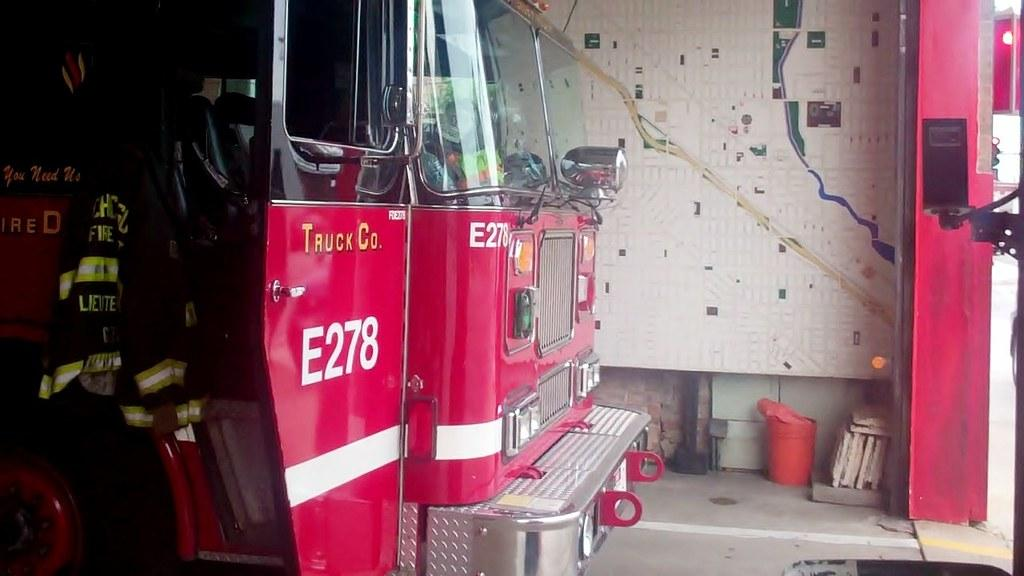What type of vehicle is in the image? There is a red color vehicle in the image. What is located in the background of the image? There is a wall in the image. What can be seen on the floor in the image? There are objects on the floor in the image. What is the price of the houses in the image? There are no houses present in the image, so it is not possible to determine the price of any houses. 